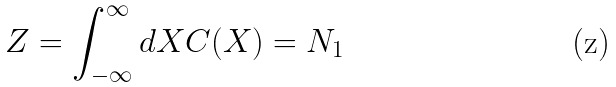<formula> <loc_0><loc_0><loc_500><loc_500>Z = \int _ { - \infty } ^ { \infty } d X C ( X ) = N _ { 1 }</formula> 